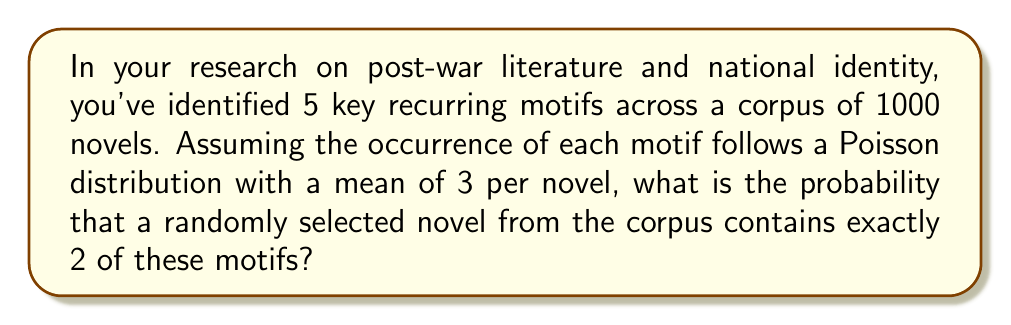Teach me how to tackle this problem. To solve this problem, we need to use the Poisson distribution formula. The Poisson distribution is used to model the number of events occurring in a fixed interval of time or space, given that these events occur with a known average rate and independently of the time since the last event.

The probability mass function of a Poisson distribution is given by:

$$ P(X = k) = \frac{e^{-\lambda} \lambda^k}{k!} $$

Where:
- $\lambda$ is the average number of events in the interval
- $k$ is the number of events we're interested in
- $e$ is Euler's number (approximately 2.71828)

In this case:
- $\lambda = 3$ (mean occurrence of motifs per novel)
- $k = 2$ (we're interested in exactly 2 motifs)

Let's plug these values into the formula:

$$ P(X = 2) = \frac{e^{-3} 3^2}{2!} $$

Now, let's calculate step by step:

1) First, calculate $e^{-3}$:
   $e^{-3} \approx 0.0497871$

2) Calculate $3^2$:
   $3^2 = 9$

3) Calculate $2!$:
   $2! = 2 \times 1 = 2$

4) Put it all together:
   $$ \frac{0.0497871 \times 9}{2} \approx 0.2240 $$

Therefore, the probability of a randomly selected novel containing exactly 2 of these motifs is approximately 0.2240 or 22.40%.
Answer: $P(X = 2) \approx 0.2240$ or $22.40\%$ 